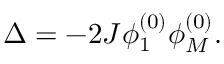Convert formula to latex. <formula><loc_0><loc_0><loc_500><loc_500>\Delta = - 2 J \phi _ { 1 } ^ { ( 0 ) } \phi _ { M } ^ { ( 0 ) } .</formula> 